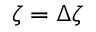<formula> <loc_0><loc_0><loc_500><loc_500>\zeta = \Delta \zeta</formula> 